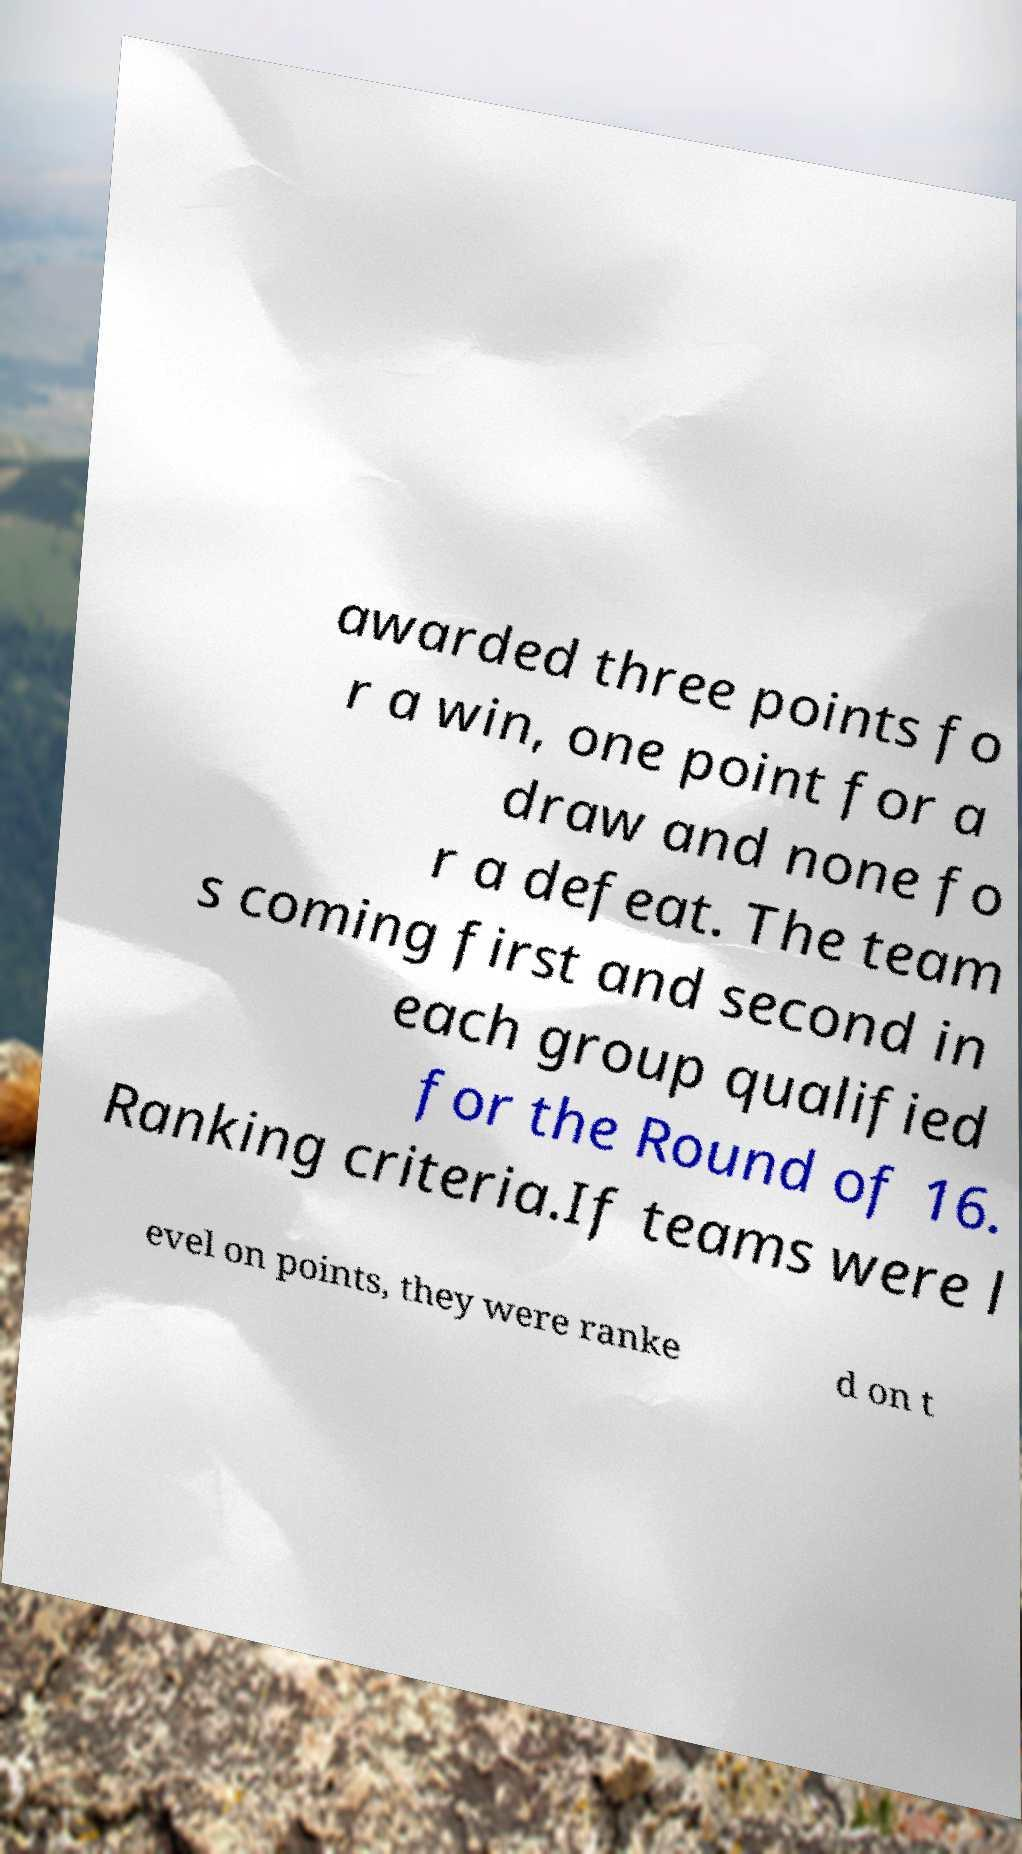Could you assist in decoding the text presented in this image and type it out clearly? awarded three points fo r a win, one point for a draw and none fo r a defeat. The team s coming first and second in each group qualified for the Round of 16. Ranking criteria.If teams were l evel on points, they were ranke d on t 